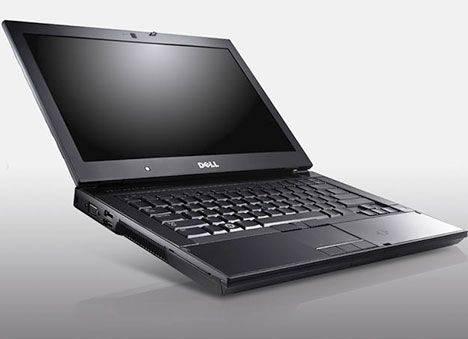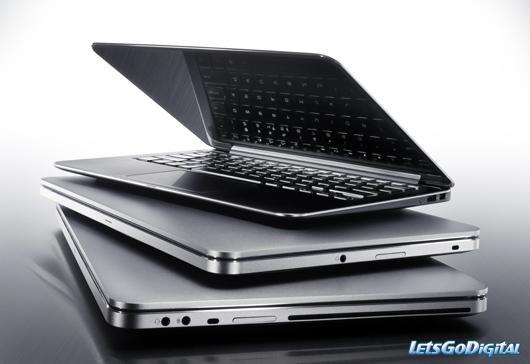The first image is the image on the left, the second image is the image on the right. Assess this claim about the two images: "The computer screen is visible in at least one of the images.". Correct or not? Answer yes or no. Yes. The first image is the image on the left, the second image is the image on the right. Assess this claim about the two images: "Each image contains only one laptop, and all laptops are open at less than a 90-degree angle and facing the same general direction.". Correct or not? Answer yes or no. No. 